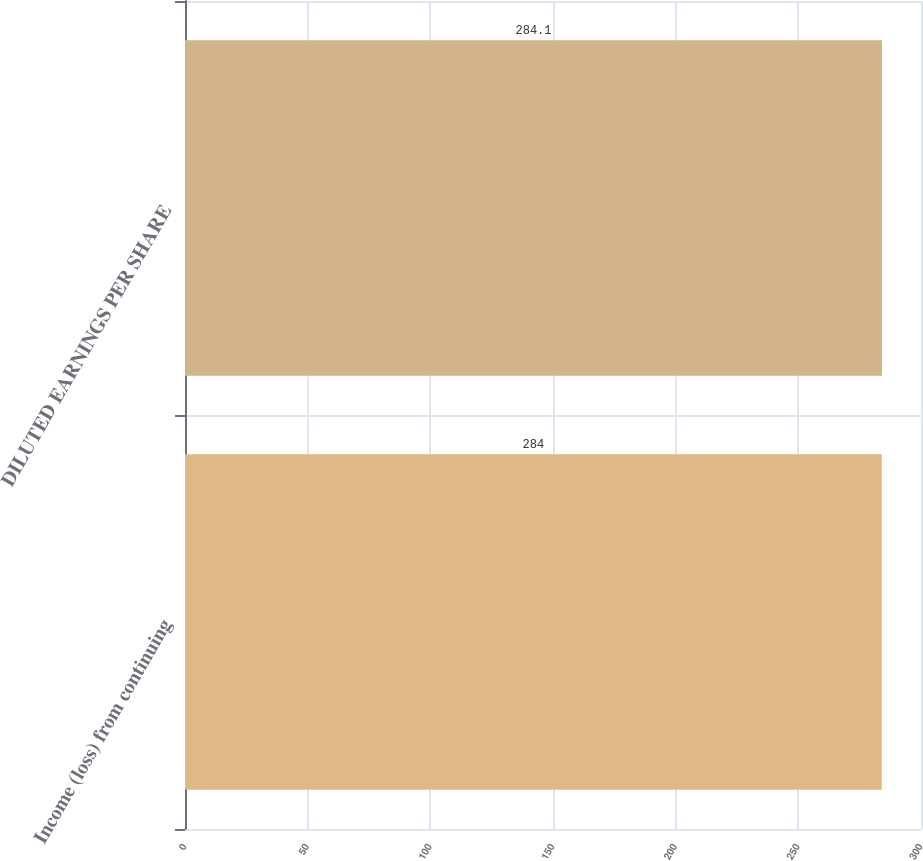Convert chart. <chart><loc_0><loc_0><loc_500><loc_500><bar_chart><fcel>Income (loss) from continuing<fcel>DILUTED EARNINGS PER SHARE<nl><fcel>284<fcel>284.1<nl></chart> 